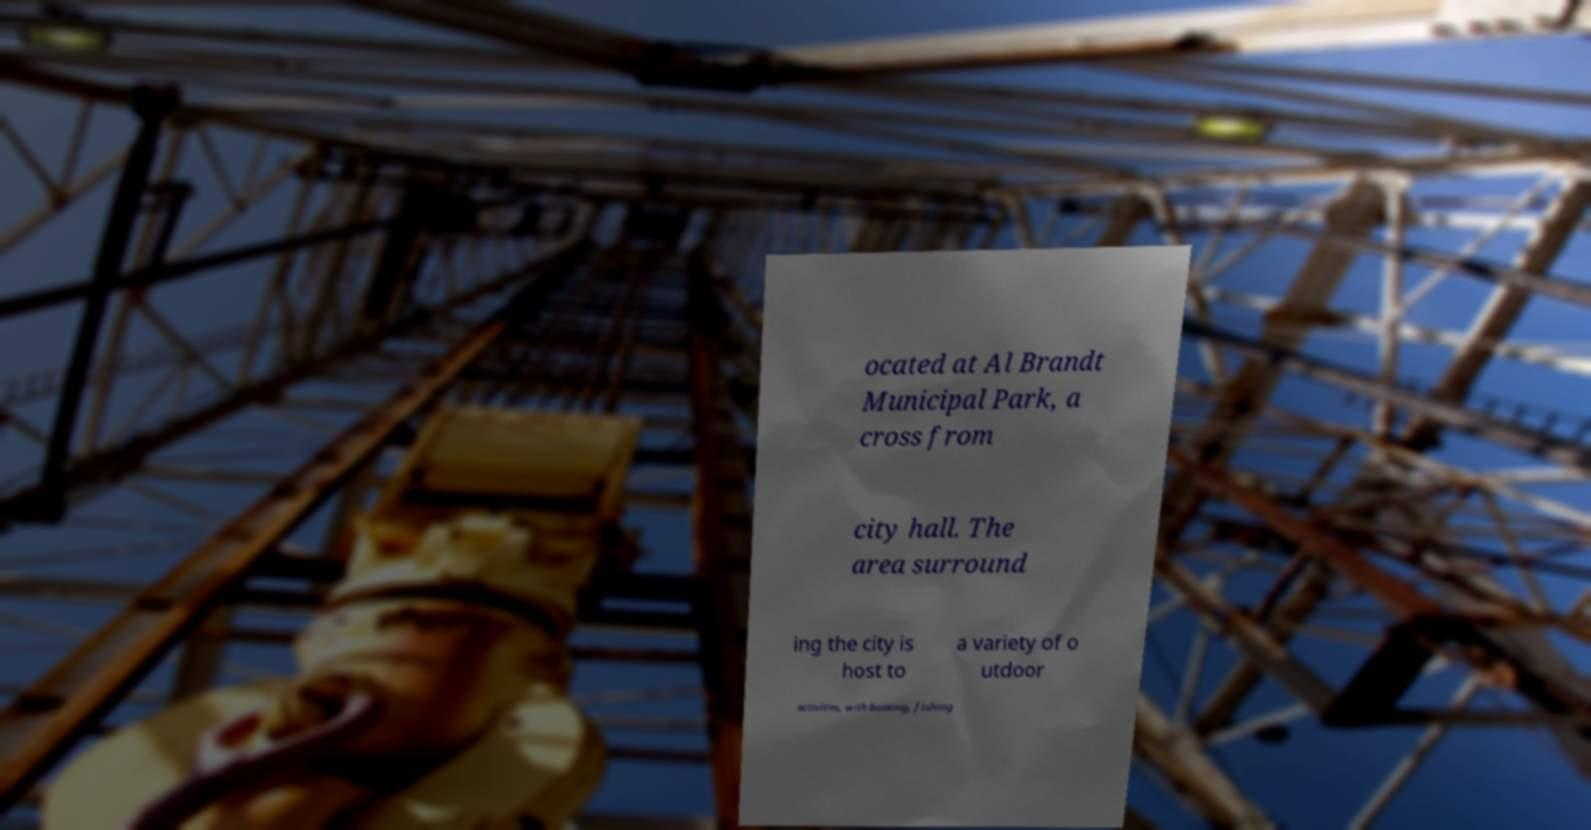Please identify and transcribe the text found in this image. ocated at Al Brandt Municipal Park, a cross from city hall. The area surround ing the city is host to a variety of o utdoor activities, with boating, fishing 